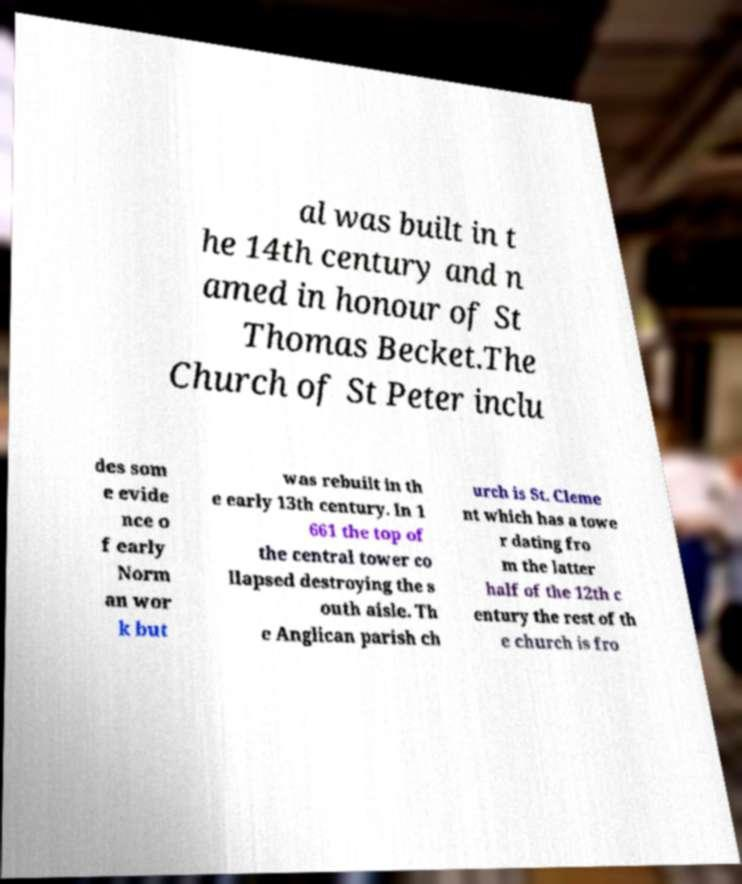Please identify and transcribe the text found in this image. al was built in t he 14th century and n amed in honour of St Thomas Becket.The Church of St Peter inclu des som e evide nce o f early Norm an wor k but was rebuilt in th e early 13th century. In 1 661 the top of the central tower co llapsed destroying the s outh aisle. Th e Anglican parish ch urch is St. Cleme nt which has a towe r dating fro m the latter half of the 12th c entury the rest of th e church is fro 